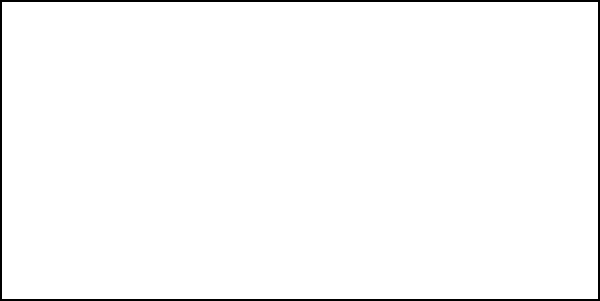You need to apply a 5 cm layer of compost to your rectangular vineyard measuring 100 m by 50 m. If the compost pile has a volume of 50 cubic meters, how many full compost piles will you need to cover the entire vineyard? To solve this problem, we'll follow these steps:

1. Calculate the area of the vineyard:
   Area = length × width
   $A = 100 \text{ m} \times 50 \text{ m} = 5000 \text{ m}^2$

2. Calculate the volume of compost needed:
   Volume = Area × depth of compost layer
   $V = 5000 \text{ m}^2 \times 0.05 \text{ m} = 250 \text{ m}^3$

3. Determine the number of compost piles needed:
   Number of piles = Volume needed ÷ Volume per pile
   $N = 250 \text{ m}^3 \div 50 \text{ m}^3 \text{ per pile} = 5 \text{ piles}$

Therefore, you will need 5 full compost piles to cover the entire vineyard with a 5 cm layer of compost.
Answer: 5 piles 